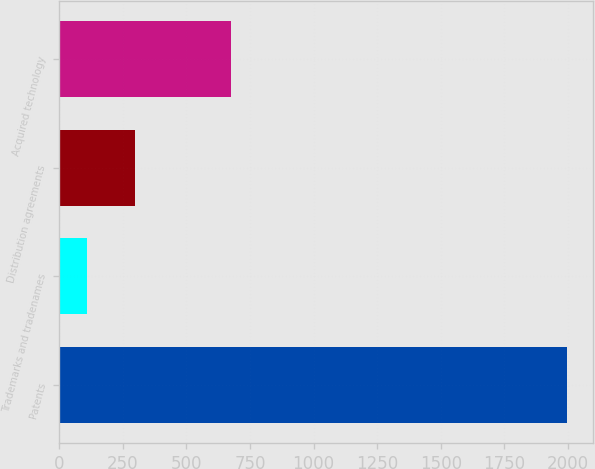Convert chart to OTSL. <chart><loc_0><loc_0><loc_500><loc_500><bar_chart><fcel>Patents<fcel>Trademarks and tradenames<fcel>Distribution agreements<fcel>Acquired technology<nl><fcel>1998<fcel>109<fcel>297.9<fcel>676<nl></chart> 